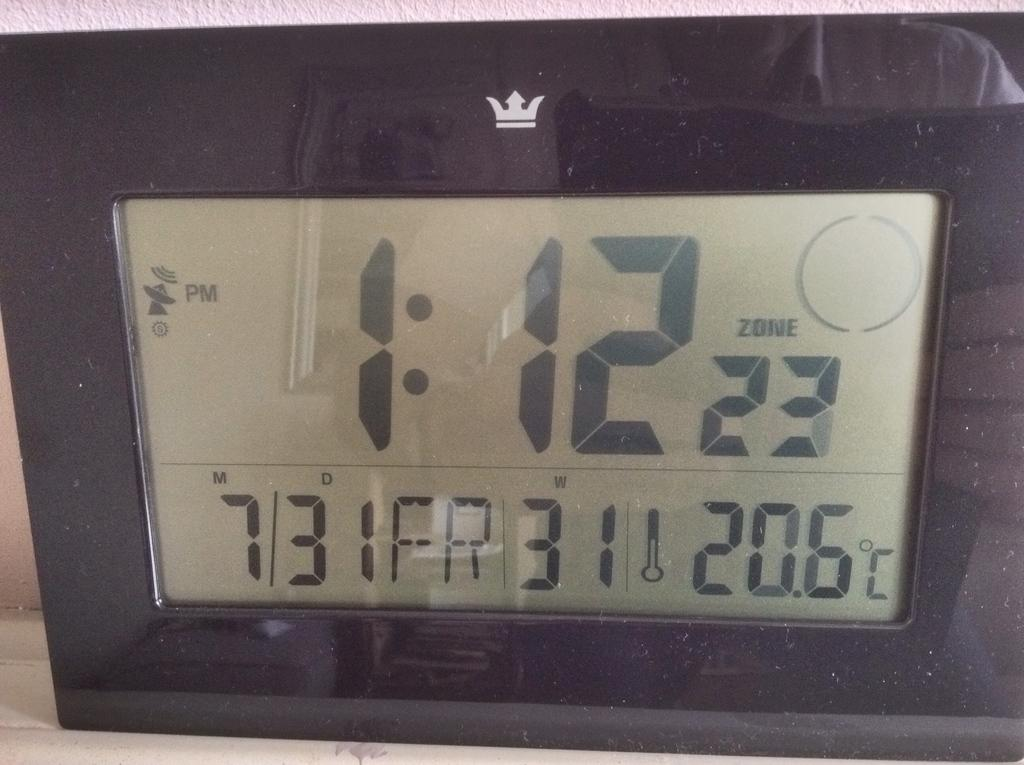<image>
Summarize the visual content of the image. A digital clock that reads 1:12 and also gives the date below. 